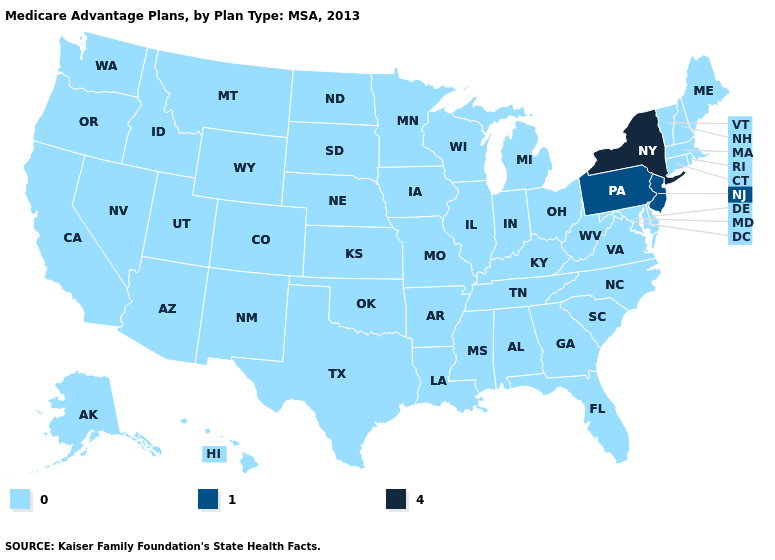What is the value of Utah?
Concise answer only. 0. What is the lowest value in the USA?
Write a very short answer. 0. What is the lowest value in the South?
Be succinct. 0. Name the states that have a value in the range 4?
Keep it brief. New York. What is the value of Arkansas?
Give a very brief answer. 0. Does Pennsylvania have the lowest value in the USA?
Answer briefly. No. What is the lowest value in the South?
Concise answer only. 0. What is the highest value in the USA?
Be succinct. 4. What is the highest value in the USA?
Concise answer only. 4. Name the states that have a value in the range 0?
Keep it brief. Alaska, Alabama, Arkansas, Arizona, California, Colorado, Connecticut, Delaware, Florida, Georgia, Hawaii, Iowa, Idaho, Illinois, Indiana, Kansas, Kentucky, Louisiana, Massachusetts, Maryland, Maine, Michigan, Minnesota, Missouri, Mississippi, Montana, North Carolina, North Dakota, Nebraska, New Hampshire, New Mexico, Nevada, Ohio, Oklahoma, Oregon, Rhode Island, South Carolina, South Dakota, Tennessee, Texas, Utah, Virginia, Vermont, Washington, Wisconsin, West Virginia, Wyoming. What is the lowest value in the Northeast?
Concise answer only. 0. Name the states that have a value in the range 1?
Write a very short answer. New Jersey, Pennsylvania. Name the states that have a value in the range 0?
Concise answer only. Alaska, Alabama, Arkansas, Arizona, California, Colorado, Connecticut, Delaware, Florida, Georgia, Hawaii, Iowa, Idaho, Illinois, Indiana, Kansas, Kentucky, Louisiana, Massachusetts, Maryland, Maine, Michigan, Minnesota, Missouri, Mississippi, Montana, North Carolina, North Dakota, Nebraska, New Hampshire, New Mexico, Nevada, Ohio, Oklahoma, Oregon, Rhode Island, South Carolina, South Dakota, Tennessee, Texas, Utah, Virginia, Vermont, Washington, Wisconsin, West Virginia, Wyoming. Among the states that border Mississippi , which have the lowest value?
Write a very short answer. Alabama, Arkansas, Louisiana, Tennessee. 